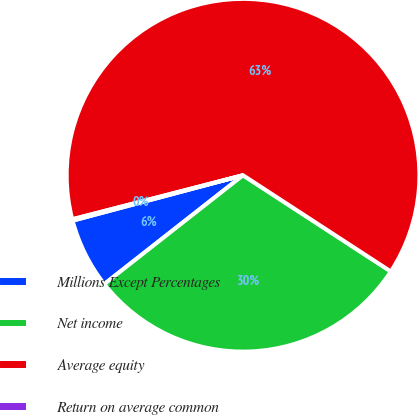Convert chart to OTSL. <chart><loc_0><loc_0><loc_500><loc_500><pie_chart><fcel>Millions Except Percentages<fcel>Net income<fcel>Average equity<fcel>Return on average common<nl><fcel>6.44%<fcel>30.23%<fcel>63.2%<fcel>0.13%<nl></chart> 